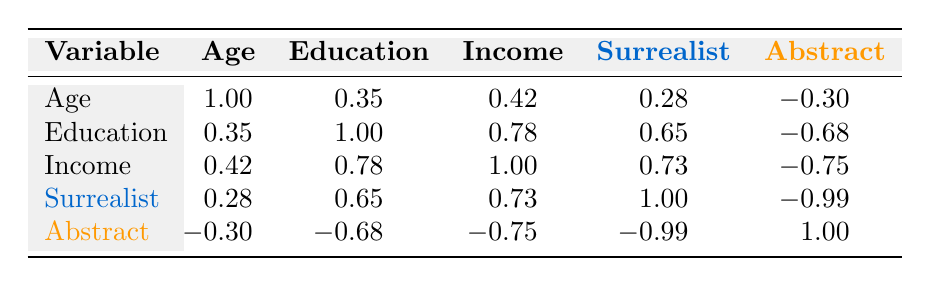What is the correlation coefficient between age and surrealist preference? The table shows that the correlation between age and surrealist preference is 0.28. This means there is a weak positive correlation, suggesting that as age increases, the preference for surrealist art also tends to increase slightly.
Answer: 0.28 Is the correlation coefficient between income and abstract preference positive or negative? The table indicates that the correlation coefficient between income and abstract preference is -0.75, which is a negative correlation. This suggests that as income increases, the preference for abstract art tends to decrease.
Answer: Negative What is the average correlation coefficient for education and surrealist preference based on the data? We look at the correlation coefficient for education and surrealist preference, which is 0.65. Since there’s only one value for this pair, the average is also 0.65.
Answer: 0.65 Does a higher education level correspond to a higher preference for surrealist art? The table shows that the correlation between education level and surrealist preference is 0.65, indicating that there is a positive correlation. Therefore, it suggests that individuals with higher education levels tend to have a higher preference for surrealist art.
Answer: Yes What is the relationship between surrealist preference and abstract preference based on the correlation coefficient? The table shows the correlation coefficient between surrealist and abstract preferences is -0.99, which is a very strong negative correlation. This indicates that as preference for surrealist art increases, the preference for abstract art decreases significantly.
Answer: Strong negative correlation What is the highest correlation coefficient in the table and which variables does it relate to? The highest correlation coefficient is -0.99, which relates to the surrealist and abstract preferences. This indicates a very strong inverse relationship between the two types of art preferences.
Answer: -0.99 (surrealist and abstract preference) Is there any correlation between age and education level? According to the table, the correlation coefficient between age and education level is 0.35, indicating a weak positive correlation. Therefore, we can conclude there is some degree of relationship, but it is relatively weak.
Answer: Yes What is the sum of the correlation coefficients involving income? To calculate this, we take the correlation coefficients related to income: 0.42 (with age) + 0.78 (with education) + 0.73 (with surrealist) - 0.75 (with abstract) = 0.18. Therefore, the total sum is 0.18.
Answer: 0.18 